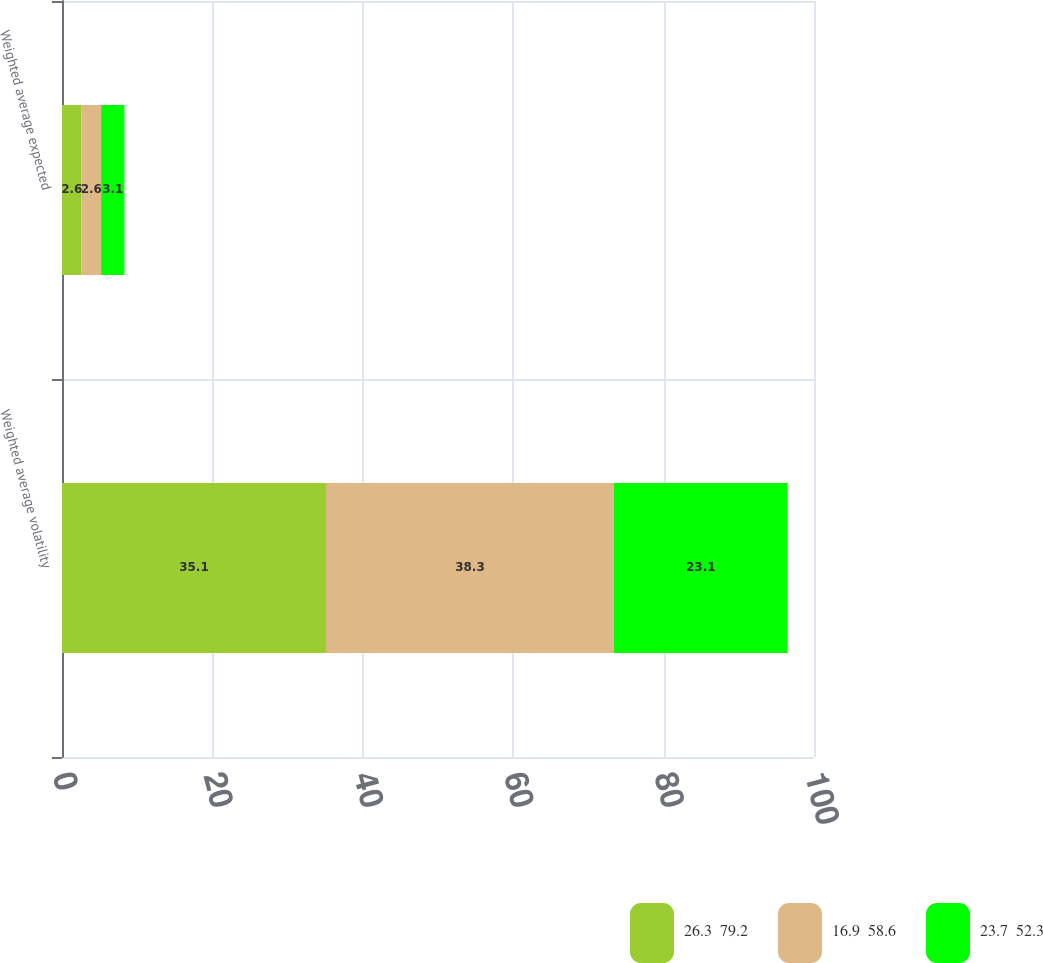Convert chart to OTSL. <chart><loc_0><loc_0><loc_500><loc_500><stacked_bar_chart><ecel><fcel>Weighted average volatility<fcel>Weighted average expected<nl><fcel>26.3  79.2<fcel>35.1<fcel>2.6<nl><fcel>16.9  58.6<fcel>38.3<fcel>2.6<nl><fcel>23.7  52.3<fcel>23.1<fcel>3.1<nl></chart> 